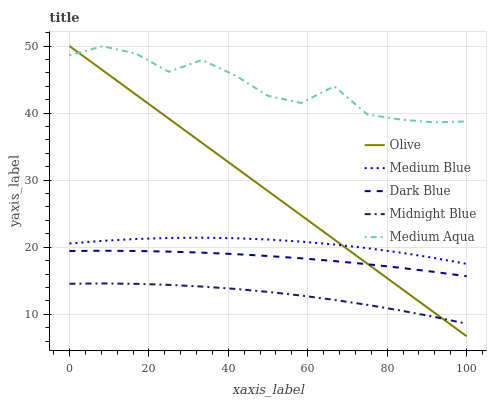Does Dark Blue have the minimum area under the curve?
Answer yes or no. No. Does Dark Blue have the maximum area under the curve?
Answer yes or no. No. Is Dark Blue the smoothest?
Answer yes or no. No. Is Dark Blue the roughest?
Answer yes or no. No. Does Dark Blue have the lowest value?
Answer yes or no. No. Does Dark Blue have the highest value?
Answer yes or no. No. Is Medium Blue less than Medium Aqua?
Answer yes or no. Yes. Is Medium Blue greater than Midnight Blue?
Answer yes or no. Yes. Does Medium Blue intersect Medium Aqua?
Answer yes or no. No. 